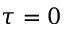<formula> <loc_0><loc_0><loc_500><loc_500>\tau = 0</formula> 